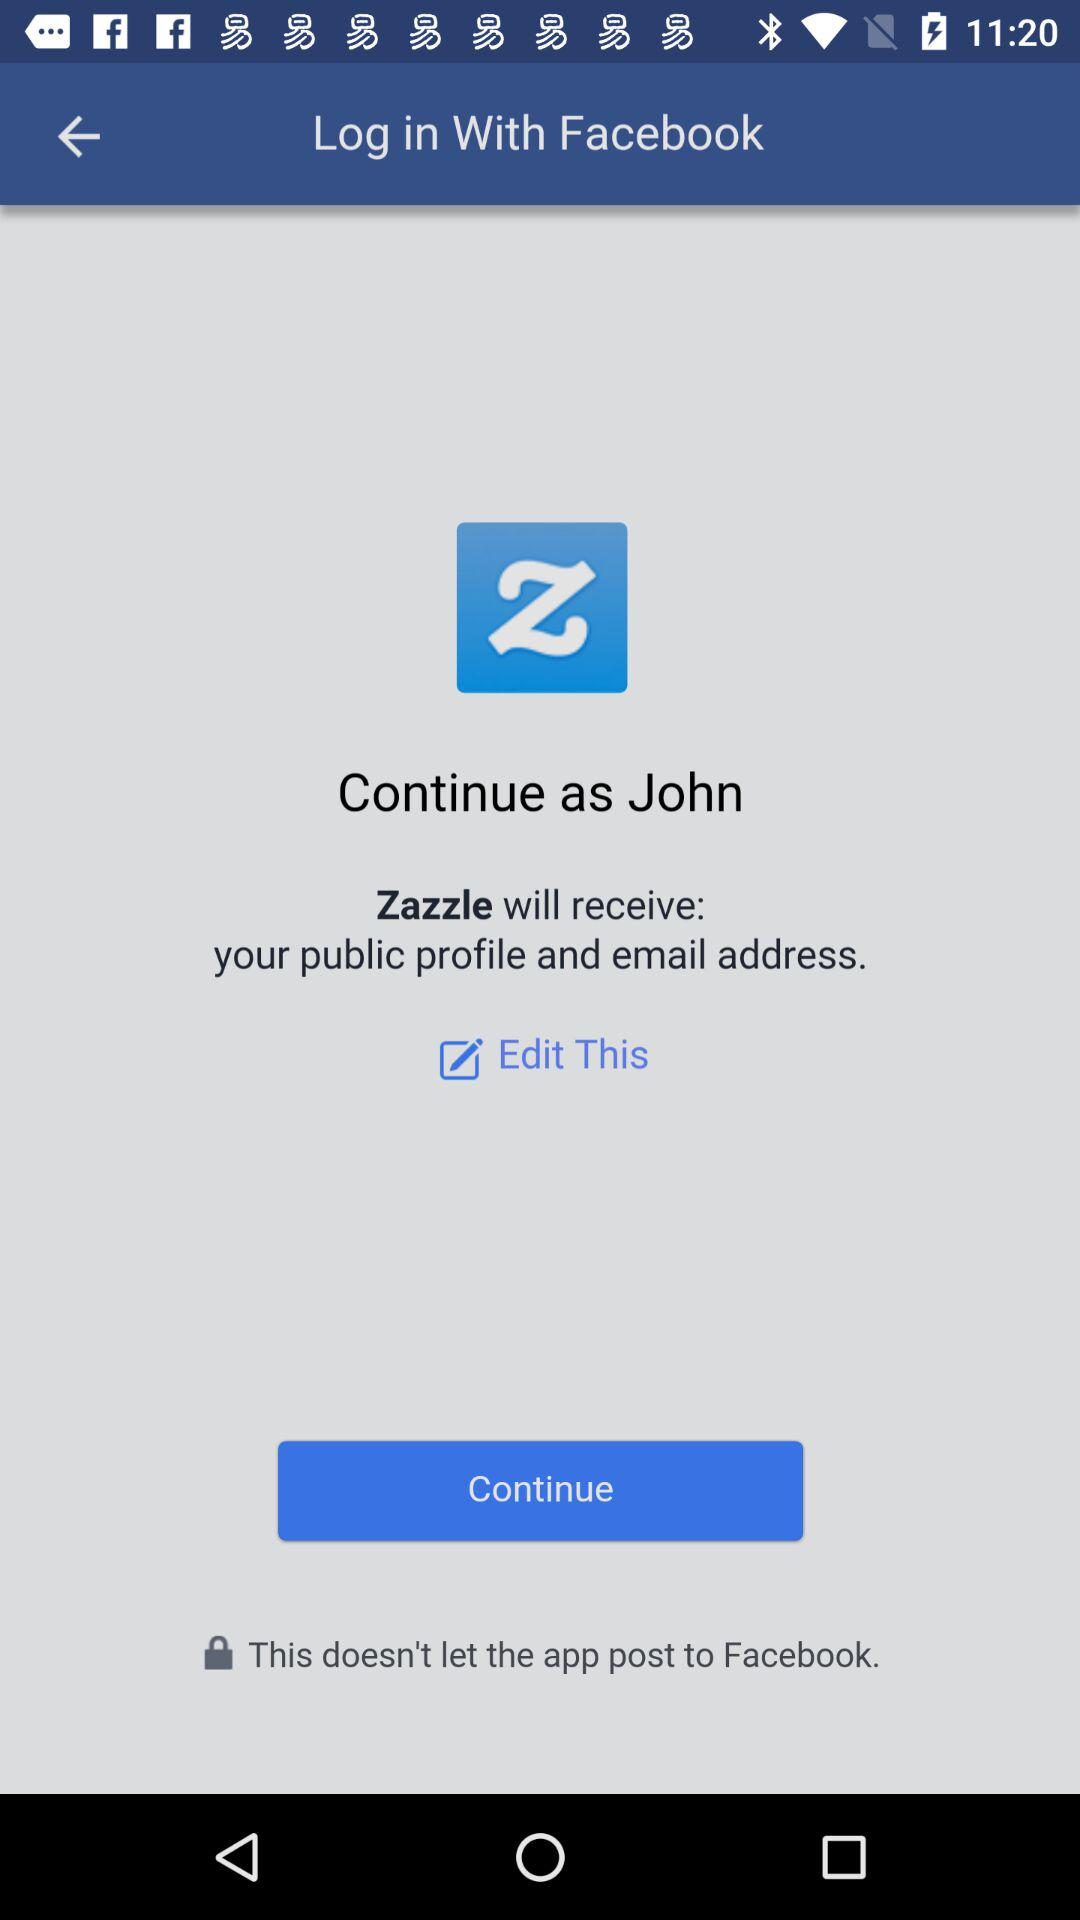Which information will "Zazzle" receive? "Zazzle" will receive your public profile and email address. 